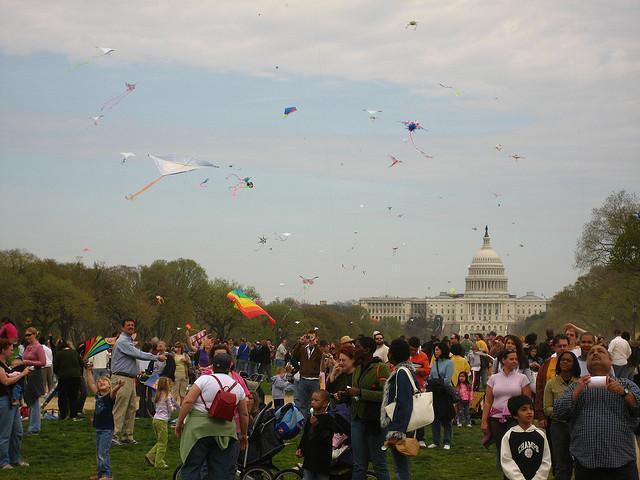How many buildings are behind the trees?
Give a very brief answer. 1. How many people are in the picture?
Give a very brief answer. 7. 